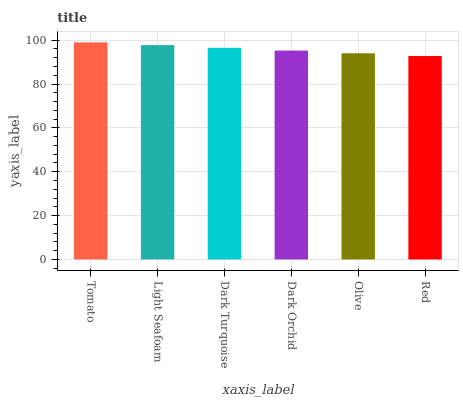Is Red the minimum?
Answer yes or no. Yes. Is Tomato the maximum?
Answer yes or no. Yes. Is Light Seafoam the minimum?
Answer yes or no. No. Is Light Seafoam the maximum?
Answer yes or no. No. Is Tomato greater than Light Seafoam?
Answer yes or no. Yes. Is Light Seafoam less than Tomato?
Answer yes or no. Yes. Is Light Seafoam greater than Tomato?
Answer yes or no. No. Is Tomato less than Light Seafoam?
Answer yes or no. No. Is Dark Turquoise the high median?
Answer yes or no. Yes. Is Dark Orchid the low median?
Answer yes or no. Yes. Is Red the high median?
Answer yes or no. No. Is Dark Turquoise the low median?
Answer yes or no. No. 